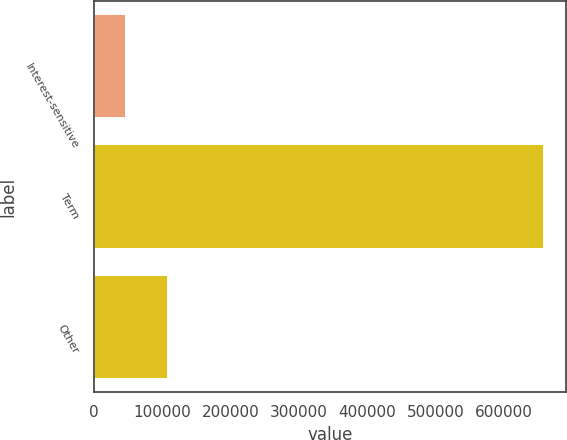<chart> <loc_0><loc_0><loc_500><loc_500><bar_chart><fcel>Interest-sensitive<fcel>Term<fcel>Other<nl><fcel>47358<fcel>657797<fcel>108402<nl></chart> 